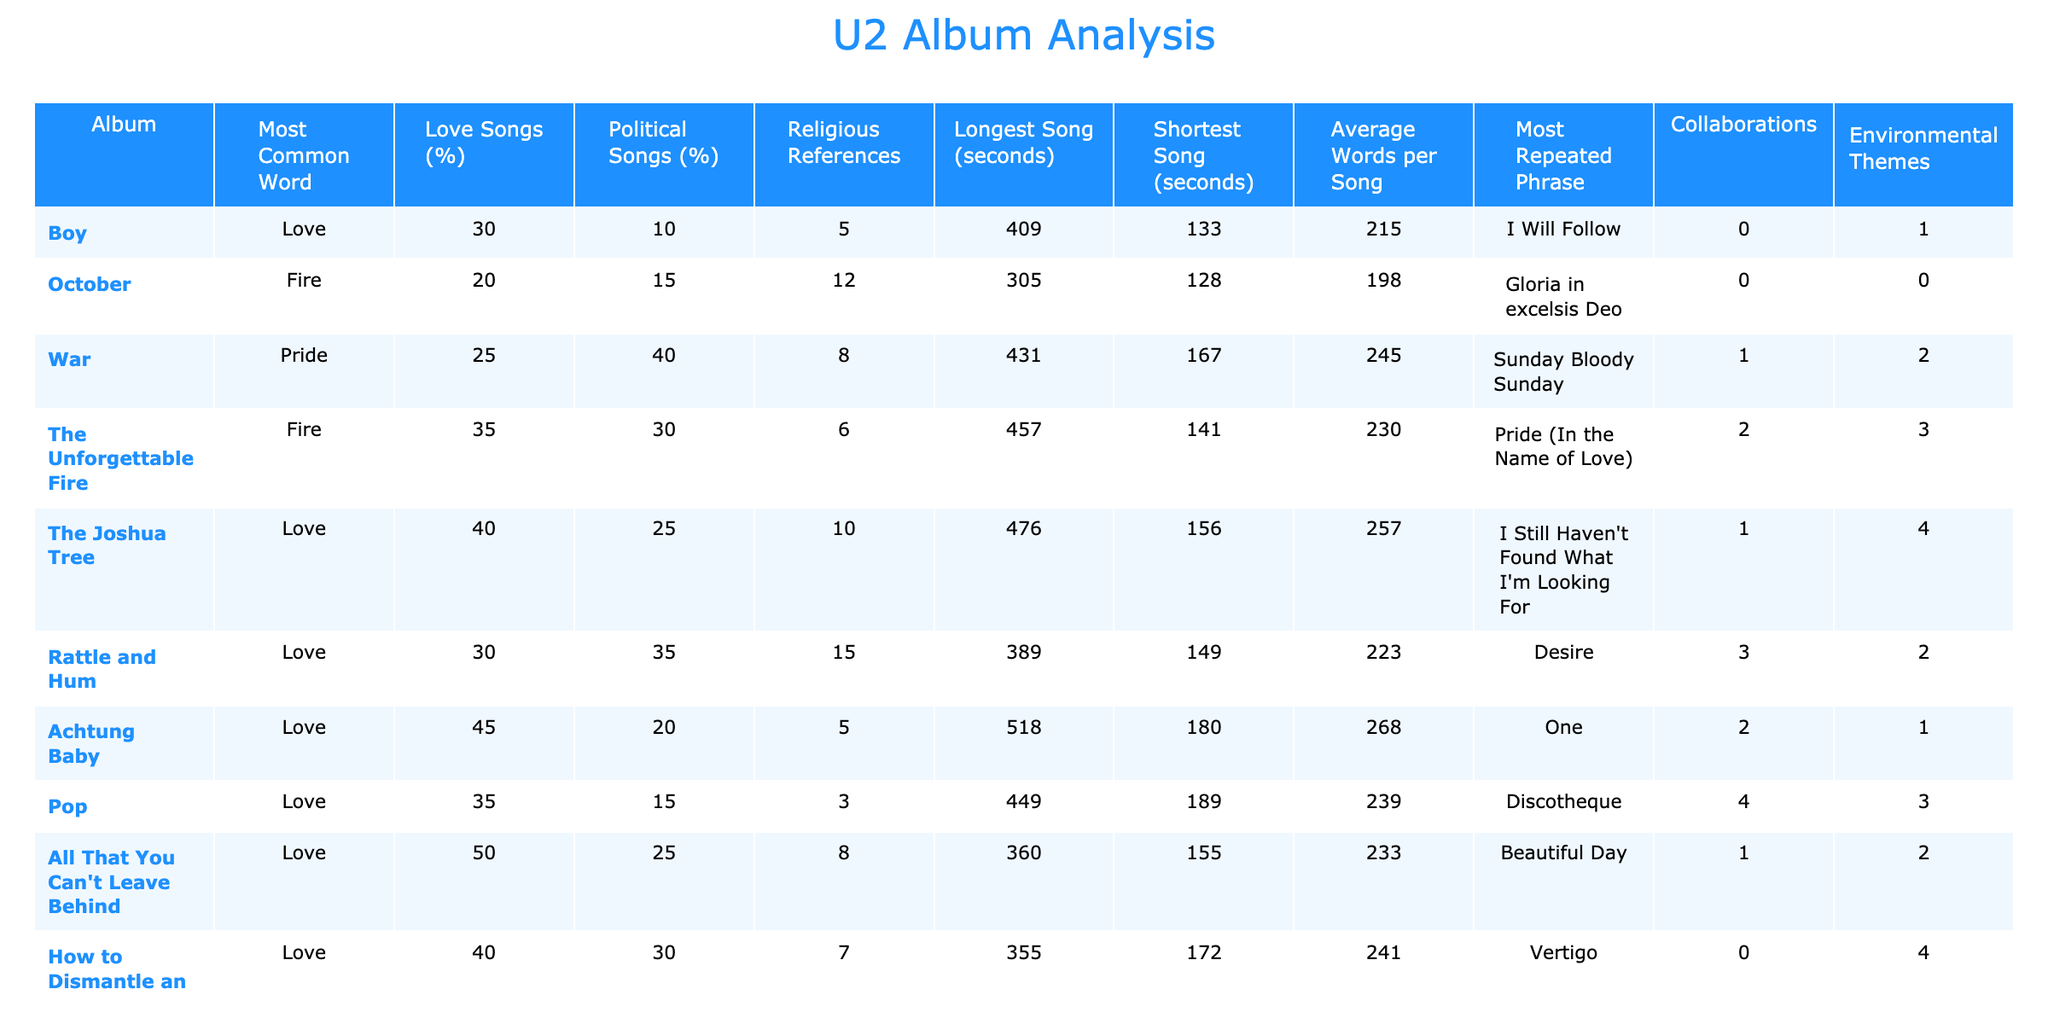What is the most common word in the album "War"? The table shows that "Pride" is the most common word for the album "War".
Answer: Pride Which album has the longest song and how long is it? Looking at the "Longest Song (seconds)" column, "Achtung Baby" has the longest song at 518 seconds.
Answer: 518 seconds How many political songs are there in the album "Songs of Experience"? The column for "Political Songs (%)" indicates that there are 40% political songs in "Songs of Experience". Assuming a standard album has about 10 songs, this means approximately 4 songs are political.
Answer: About 4 songs Which album has the highest percentage of love songs? By examining the "Love Songs (%)" column, we see that "All That You Can't Leave Behind" has the highest percentage at 50%.
Answer: 50% Do any albums collaborate with other artists, and if so, which ones? The "Collaborations" column shows that both "Rattle and Hum" (3) and "Pop" (4) have collaborations with other artists.
Answer: Yes, "Rattle and Hum" and "Pop" What is the average number of words per song across all albums? To find the average, sum all the values in the "Average Words per Song" column (215 + 198 + 245 + 230 + 257 + 223 + 268 + 239 + 233 + 241 + 252 + 247 + 259) equals 3023. Dividing by 13 albums gives an average of about 232.54 words per song.
Answer: About 232.54 words Which album has the most environmental themes? The "Environmental Themes" column indicates that "Achtung Baby" has the highest mention of environmental themes, with 1 as its value.
Answer: 1 Is there a relationship between the longest song duration and the number of love songs in the albums? "Achtung Baby" has the longest song at 518 seconds and 45% love songs. Meanwhile, "October," which is shorter at 305 seconds, has 20% love songs. This implies that longer songs don't necessarily correlate with more love songs.
Answer: No direct correlation What is the total count of religious references across all albums? Adding the values in the "Religious References" column gives us a total of (5 + 12 + 8 + 6 + 10 + 15 + 5 + 3 + 8 + 9 + 6 + 8) = 103 religious references across all albums.
Answer: 103 references Which albums feature the phrase "I Still Haven't Found What I'm Looking For"? The phrase appears in "The Joshua Tree" album as listed in the "Most Repeated Phrase" column.
Answer: The Joshua Tree 